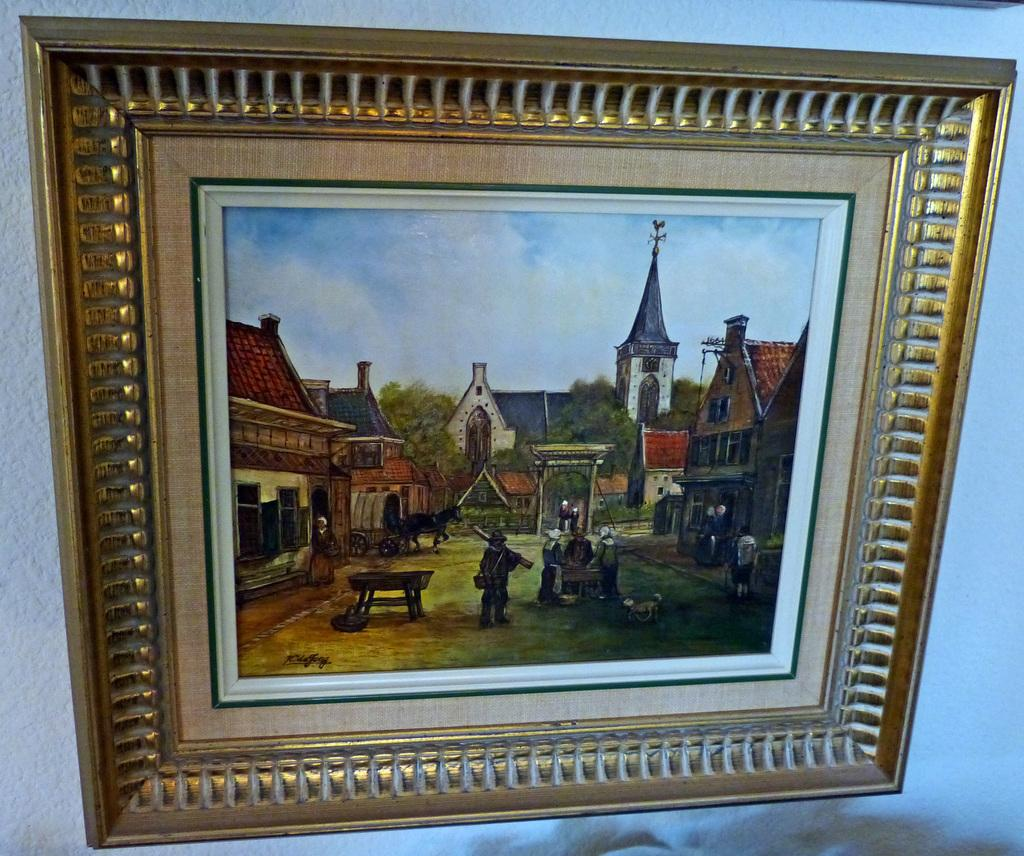What type of structures can be seen in the image? There are buildings in the image. Who or what else is present in the image? There are people and bullock carts in the image. What other natural elements can be seen in the image? There are trees in the image. Are there any man-made objects besides buildings? Yes, there are poles and stands in the image. What architectural feature is present in the image? There is an arch in the image. What is the purpose of the cloth at the bottom of the image? The purpose of the cloth is not clear from the image, but it could be used for decoration or to cover something. How many babies are sitting on the roof of the buildings in the image? There are no babies present in the image; it only shows buildings, people, trees, poles, bullock carts, stands, an arch, and a cloth. What type of tooth is visible on the top of the arch in the image? There is no tooth present on the top of the arch or anywhere else in the image. 